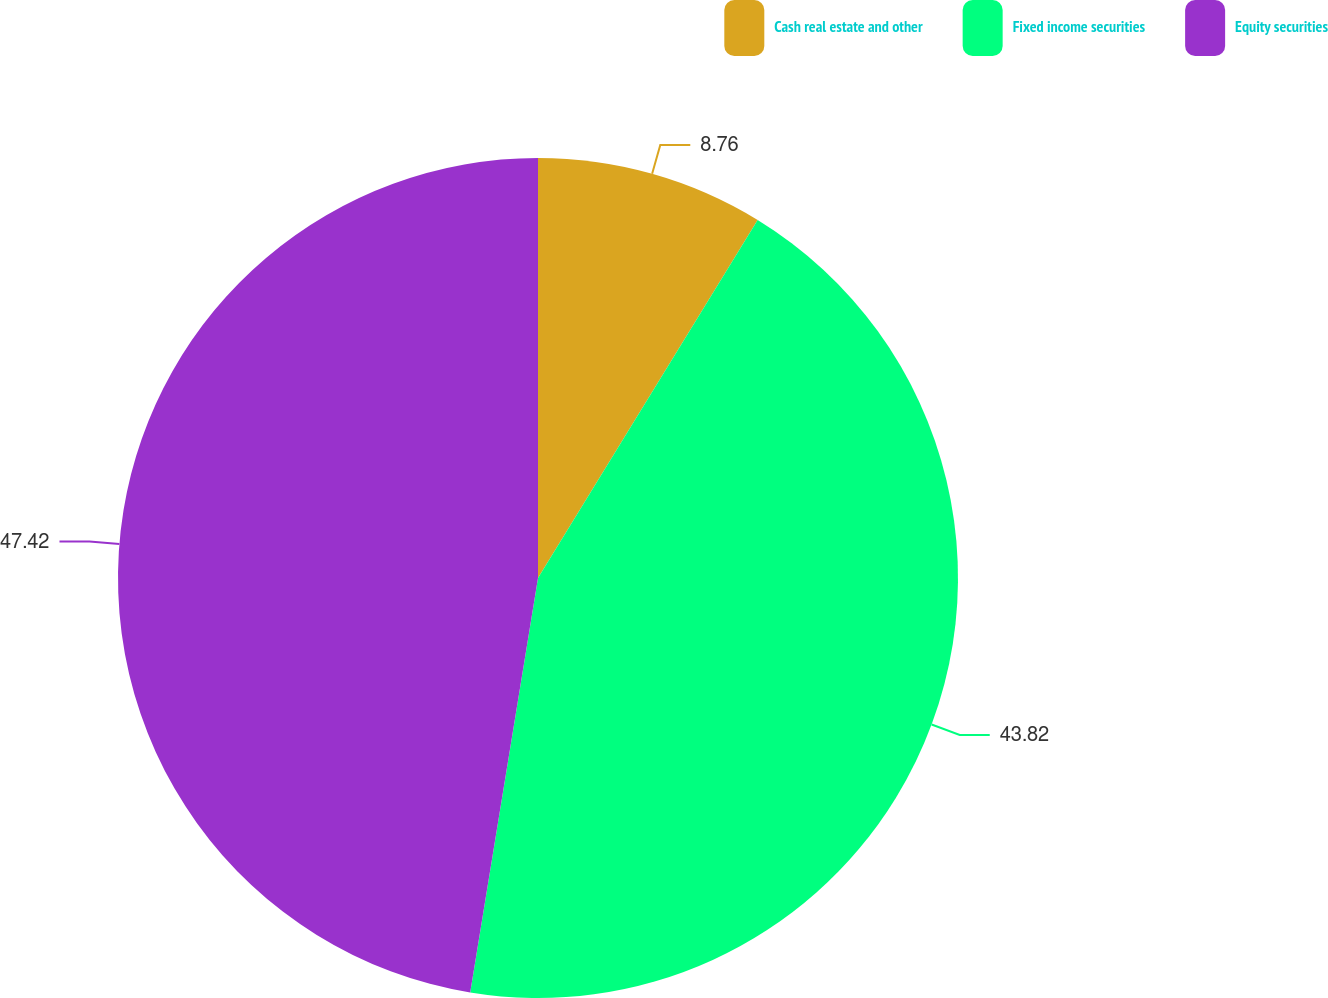<chart> <loc_0><loc_0><loc_500><loc_500><pie_chart><fcel>Cash real estate and other<fcel>Fixed income securities<fcel>Equity securities<nl><fcel>8.76%<fcel>43.82%<fcel>47.42%<nl></chart> 